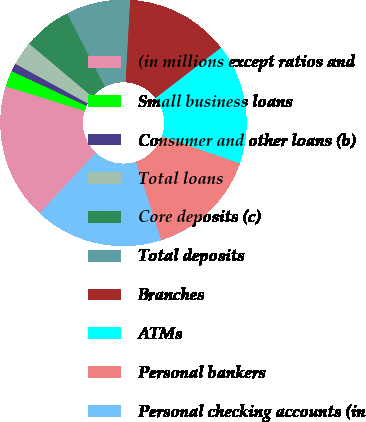<chart> <loc_0><loc_0><loc_500><loc_500><pie_chart><fcel>(in millions except ratios and<fcel>Small business loans<fcel>Consumer and other loans (b)<fcel>Total loans<fcel>Core deposits (c)<fcel>Total deposits<fcel>Branches<fcel>ATMs<fcel>Personal bankers<fcel>Personal checking accounts (in<nl><fcel>17.89%<fcel>2.11%<fcel>1.06%<fcel>3.16%<fcel>6.32%<fcel>8.42%<fcel>13.68%<fcel>15.78%<fcel>14.73%<fcel>16.84%<nl></chart> 